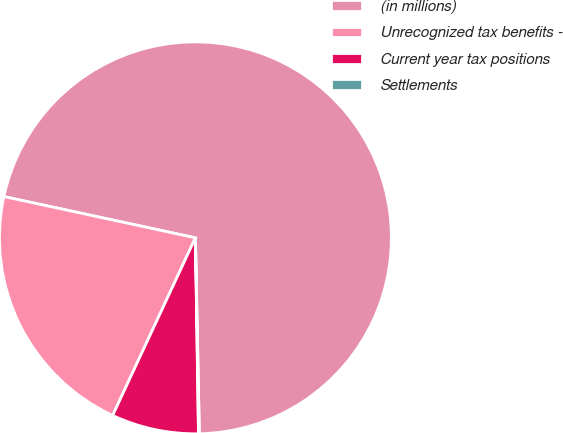Convert chart. <chart><loc_0><loc_0><loc_500><loc_500><pie_chart><fcel>(in millions)<fcel>Unrecognized tax benefits -<fcel>Current year tax positions<fcel>Settlements<nl><fcel>71.3%<fcel>21.44%<fcel>7.19%<fcel>0.07%<nl></chart> 